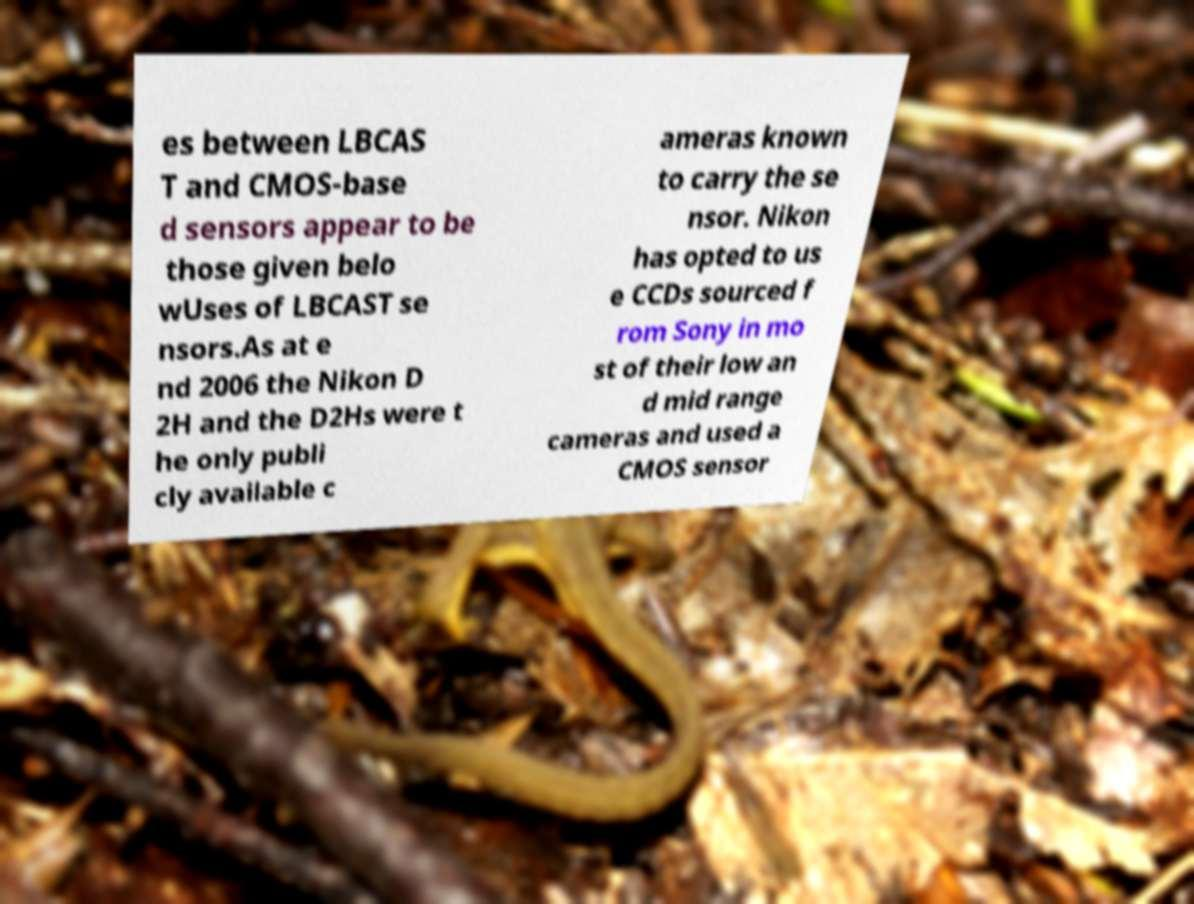Could you assist in decoding the text presented in this image and type it out clearly? es between LBCAS T and CMOS-base d sensors appear to be those given belo wUses of LBCAST se nsors.As at e nd 2006 the Nikon D 2H and the D2Hs were t he only publi cly available c ameras known to carry the se nsor. Nikon has opted to us e CCDs sourced f rom Sony in mo st of their low an d mid range cameras and used a CMOS sensor 